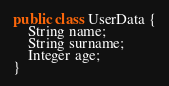Convert code to text. <code><loc_0><loc_0><loc_500><loc_500><_Java_>public class UserData {
    String name;
    String surname;
    Integer age;
}
</code> 